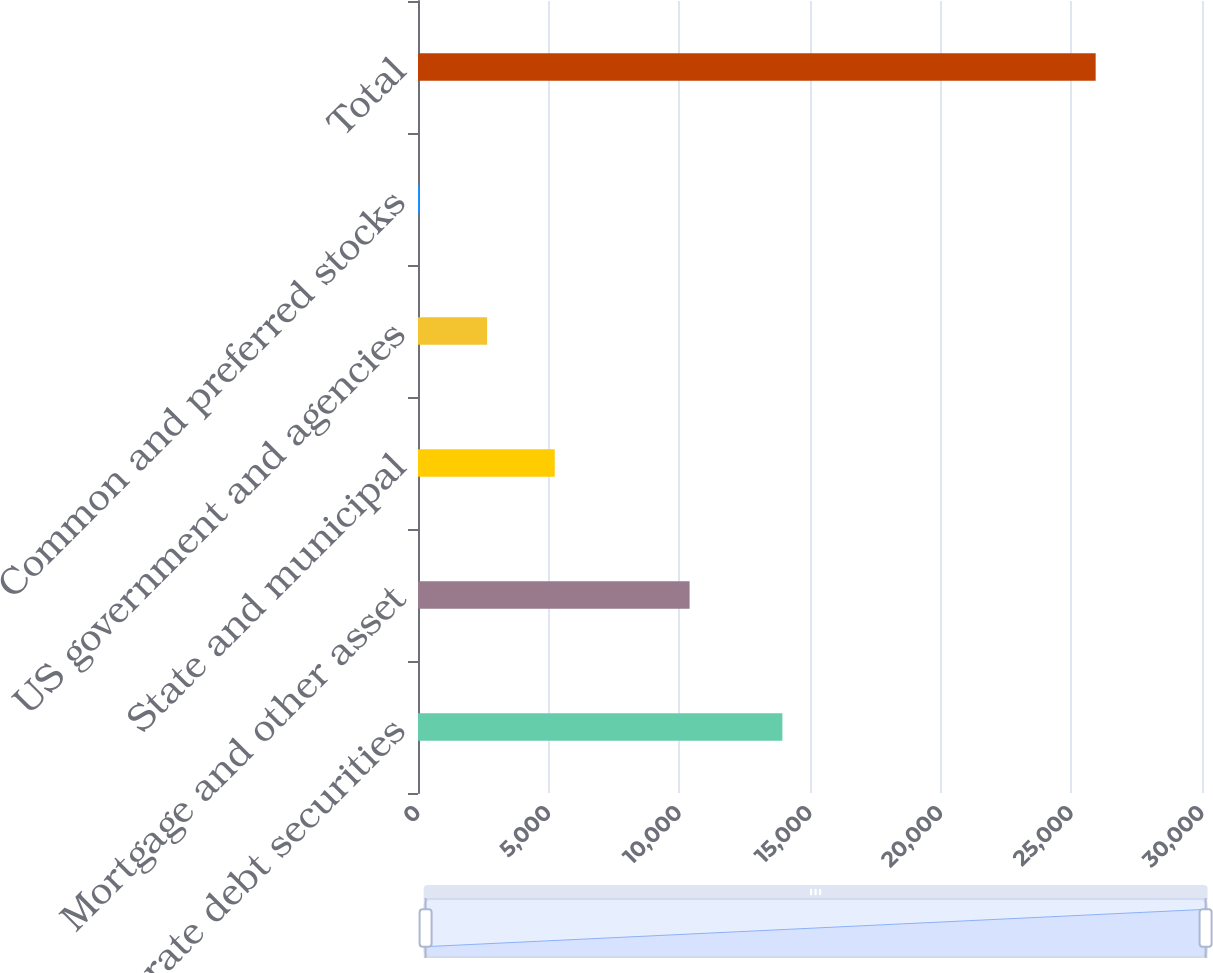<chart> <loc_0><loc_0><loc_500><loc_500><bar_chart><fcel>Corporate debt securities<fcel>Mortgage and other asset<fcel>State and municipal<fcel>US government and agencies<fcel>Common and preferred stocks<fcel>Total<nl><fcel>13943<fcel>10393<fcel>5232.6<fcel>2645.3<fcel>58<fcel>25931<nl></chart> 